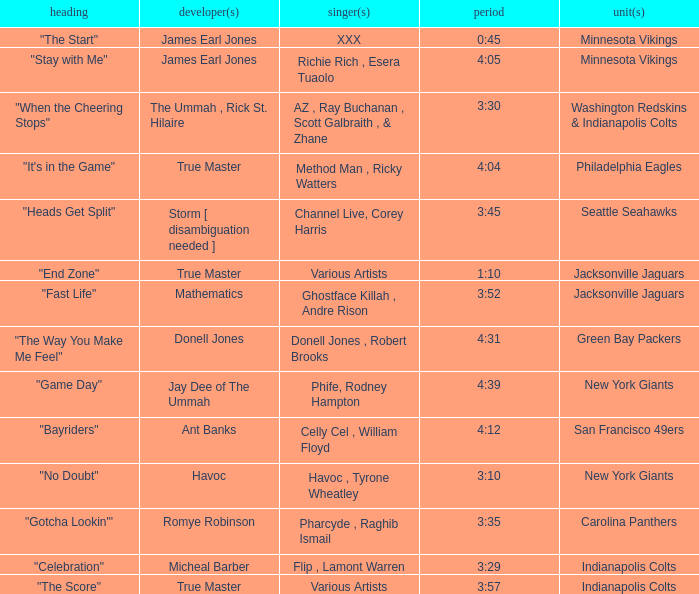Who is the artist of the Seattle Seahawks track? Channel Live, Corey Harris. 